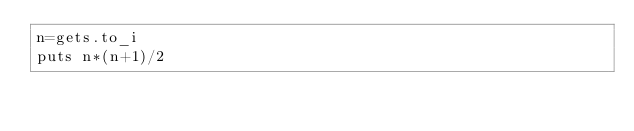Convert code to text. <code><loc_0><loc_0><loc_500><loc_500><_Ruby_>n=gets.to_i
puts n*(n+1)/2
</code> 